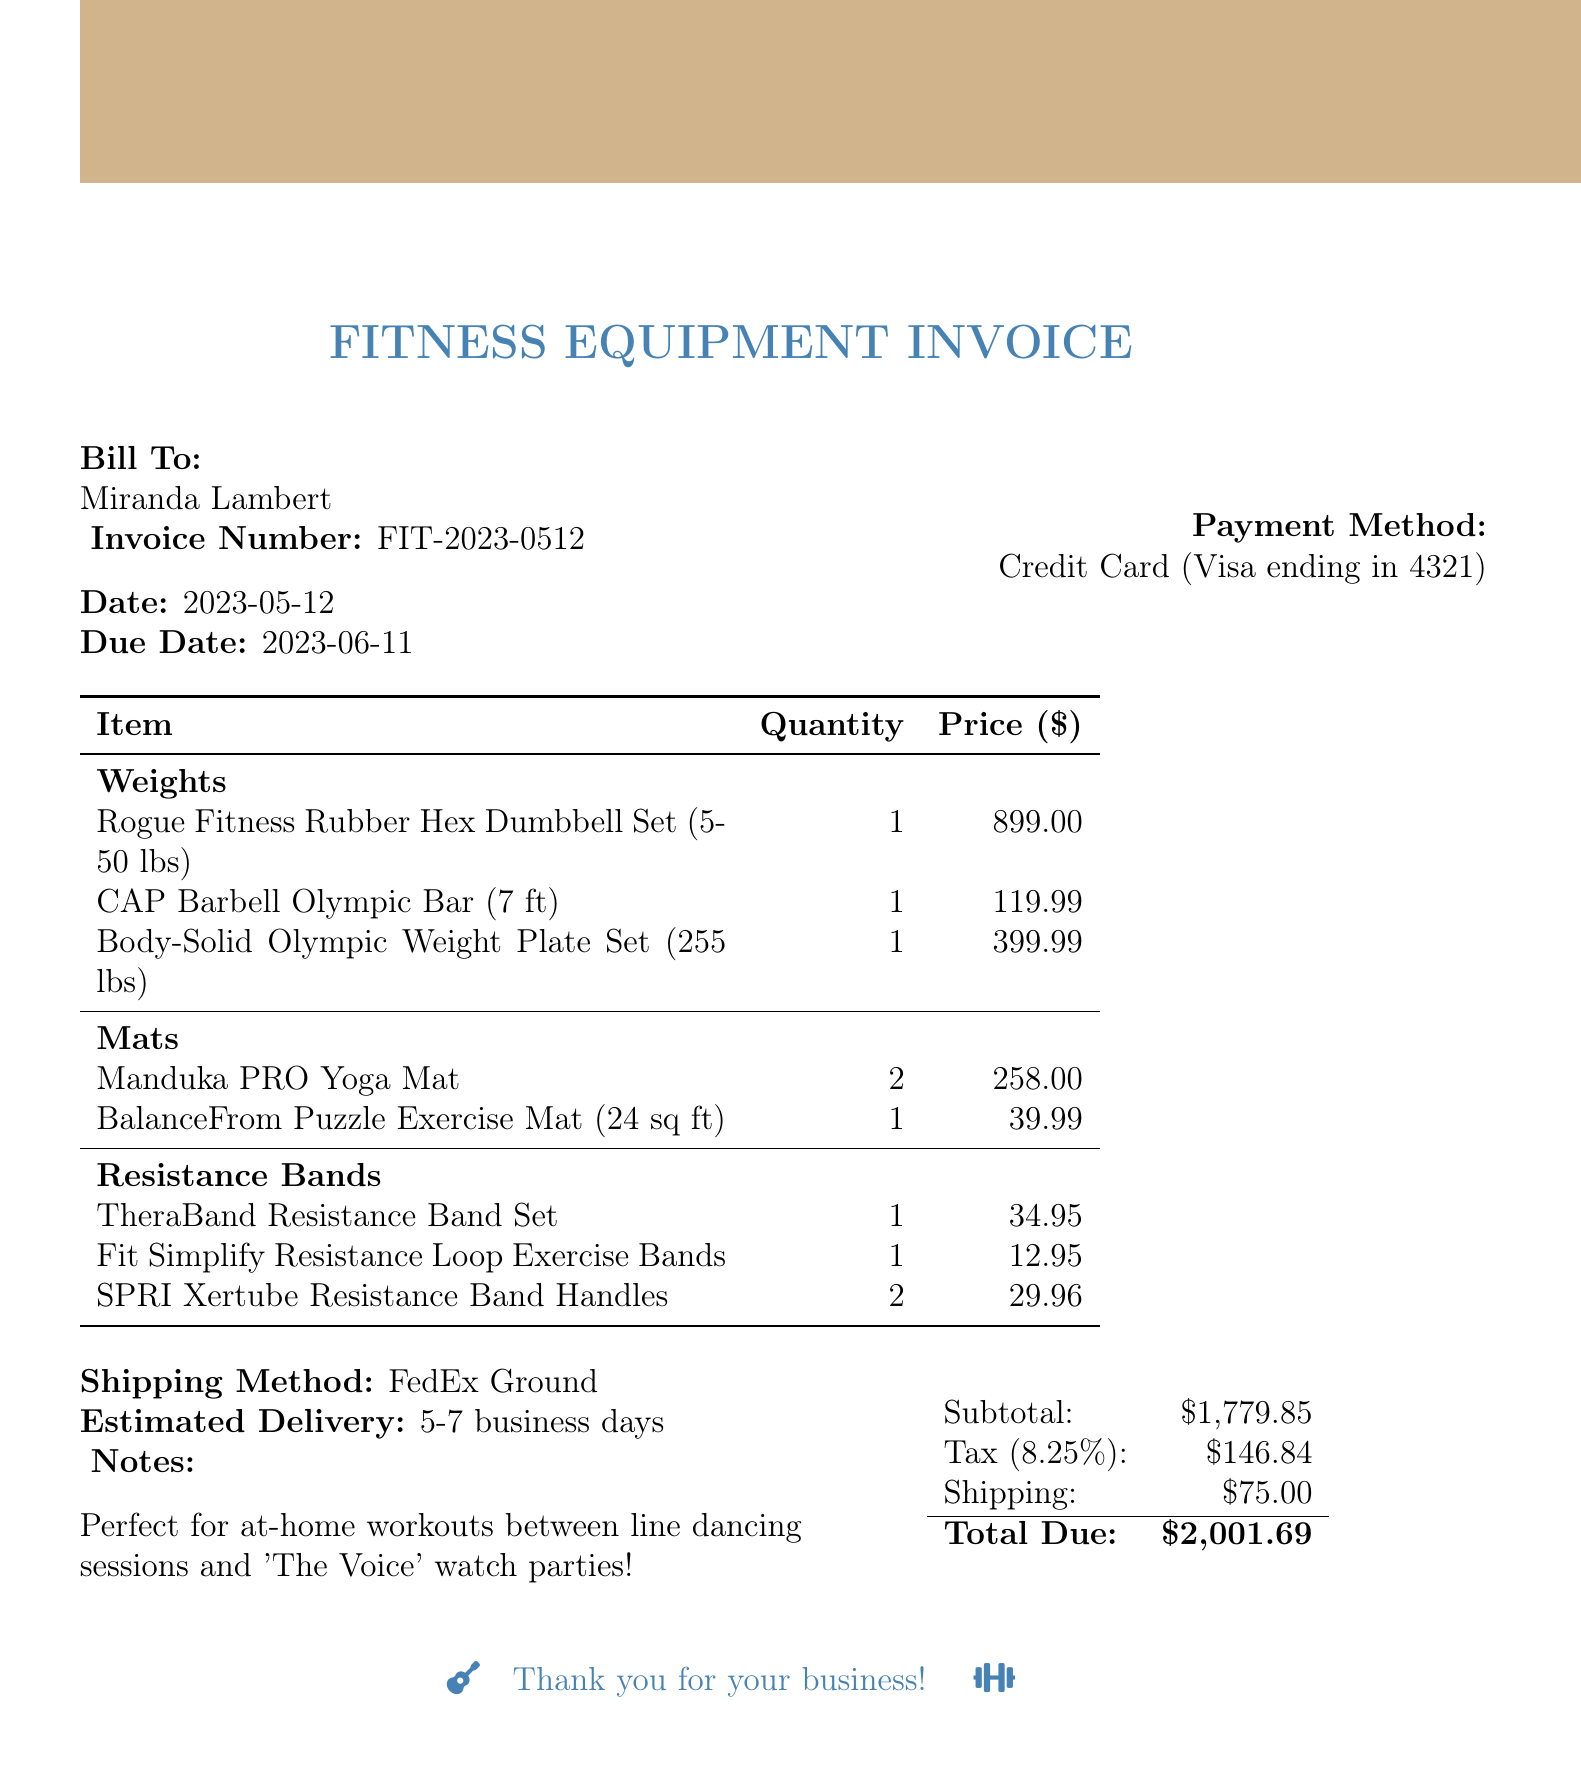What is the invoice number? The invoice number is a unique identifier for the transaction, which can be found at the top of the document.
Answer: FIT-2023-0512 What is the date of the invoice? The date of the invoice indicates when the transaction was created, located in the document details.
Answer: 2023-05-12 Who is the client? The client's name is listed in the billing section of the invoice.
Answer: Miranda Lambert What is the shipping cost? The shipping cost is specified in the additional information section of the document.
Answer: 75.00 What is the total due? The total due is the sum of the subtotal, tax, and shipping costs, presented at the bottom of the invoice.
Answer: 2001.69 How many Manduka PRO Yoga Mats were purchased? The quantity of Manduka PRO Yoga Mats can be found in the itemized equipment list under mats.
Answer: 2 What is the tax rate applied to the invoice? The tax rate is indicated in the financial summary of the invoice.
Answer: 0.0825 What payment method was used? The payment method is provided in the payment section of the document.
Answer: Credit Card (Visa ending in 4321) What is noted as a benefit of the purchased equipment? The note section provides insights on the purpose of the equipment purchase.
Answer: Perfect for at-home workouts between line dancing sessions and 'The Voice' watch parties! 